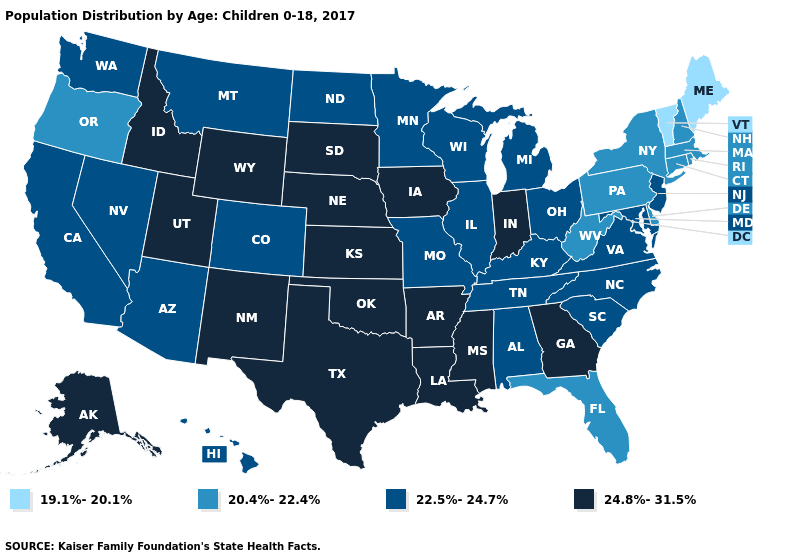Among the states that border Alabama , which have the lowest value?
Quick response, please. Florida. Name the states that have a value in the range 22.5%-24.7%?
Be succinct. Alabama, Arizona, California, Colorado, Hawaii, Illinois, Kentucky, Maryland, Michigan, Minnesota, Missouri, Montana, Nevada, New Jersey, North Carolina, North Dakota, Ohio, South Carolina, Tennessee, Virginia, Washington, Wisconsin. What is the value of Connecticut?
Write a very short answer. 20.4%-22.4%. Does Texas have the highest value in the USA?
Give a very brief answer. Yes. Does Utah have the lowest value in the West?
Give a very brief answer. No. What is the highest value in states that border North Carolina?
Give a very brief answer. 24.8%-31.5%. Among the states that border Oregon , which have the highest value?
Concise answer only. Idaho. Name the states that have a value in the range 24.8%-31.5%?
Be succinct. Alaska, Arkansas, Georgia, Idaho, Indiana, Iowa, Kansas, Louisiana, Mississippi, Nebraska, New Mexico, Oklahoma, South Dakota, Texas, Utah, Wyoming. Name the states that have a value in the range 22.5%-24.7%?
Short answer required. Alabama, Arizona, California, Colorado, Hawaii, Illinois, Kentucky, Maryland, Michigan, Minnesota, Missouri, Montana, Nevada, New Jersey, North Carolina, North Dakota, Ohio, South Carolina, Tennessee, Virginia, Washington, Wisconsin. Name the states that have a value in the range 19.1%-20.1%?
Answer briefly. Maine, Vermont. Does Maryland have the highest value in the South?
Be succinct. No. Does Alabama have a higher value than Florida?
Answer briefly. Yes. Name the states that have a value in the range 22.5%-24.7%?
Keep it brief. Alabama, Arizona, California, Colorado, Hawaii, Illinois, Kentucky, Maryland, Michigan, Minnesota, Missouri, Montana, Nevada, New Jersey, North Carolina, North Dakota, Ohio, South Carolina, Tennessee, Virginia, Washington, Wisconsin. Name the states that have a value in the range 24.8%-31.5%?
Write a very short answer. Alaska, Arkansas, Georgia, Idaho, Indiana, Iowa, Kansas, Louisiana, Mississippi, Nebraska, New Mexico, Oklahoma, South Dakota, Texas, Utah, Wyoming. Name the states that have a value in the range 22.5%-24.7%?
Give a very brief answer. Alabama, Arizona, California, Colorado, Hawaii, Illinois, Kentucky, Maryland, Michigan, Minnesota, Missouri, Montana, Nevada, New Jersey, North Carolina, North Dakota, Ohio, South Carolina, Tennessee, Virginia, Washington, Wisconsin. 